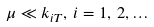Convert formula to latex. <formula><loc_0><loc_0><loc_500><loc_500>\mu \ll k _ { i T } , \, i = 1 , \, 2 , \dots</formula> 